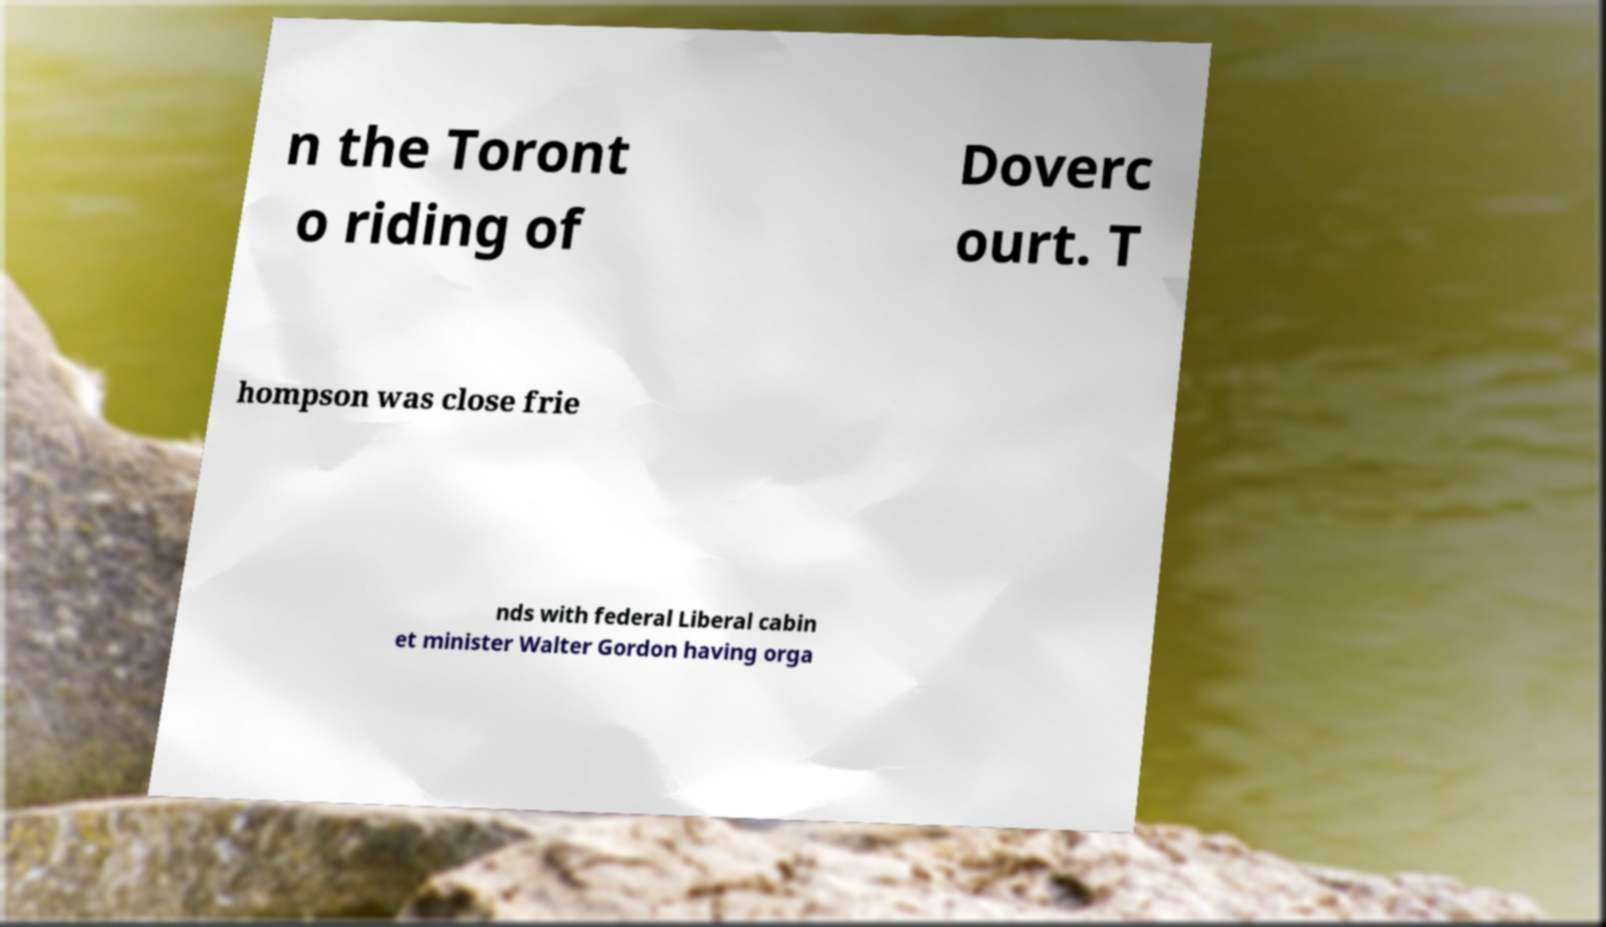Can you accurately transcribe the text from the provided image for me? n the Toront o riding of Doverc ourt. T hompson was close frie nds with federal Liberal cabin et minister Walter Gordon having orga 